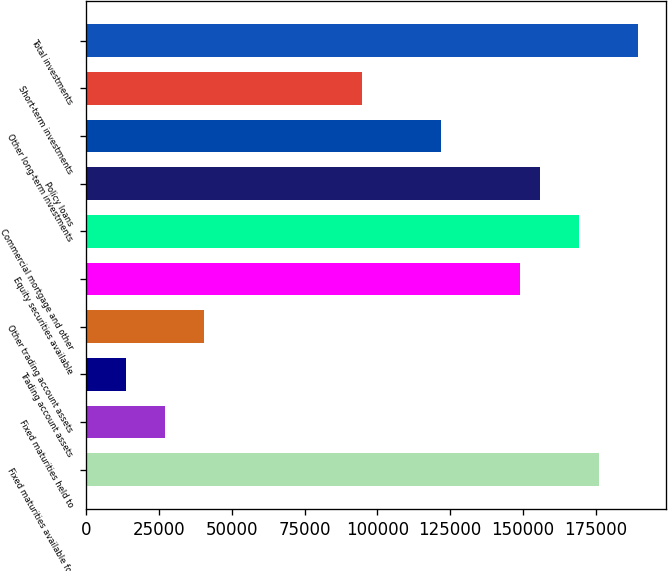Convert chart. <chart><loc_0><loc_0><loc_500><loc_500><bar_chart><fcel>Fixed maturities available for<fcel>Fixed maturities held to<fcel>Trading account assets<fcel>Other trading account assets<fcel>Equity securities available<fcel>Commercial mortgage and other<fcel>Policy loans<fcel>Other long-term investments<fcel>Short-term investments<fcel>Total investments<nl><fcel>176040<fcel>27083.6<fcel>13542.1<fcel>40625.1<fcel>148957<fcel>169269<fcel>155728<fcel>121874<fcel>94790.9<fcel>189581<nl></chart> 